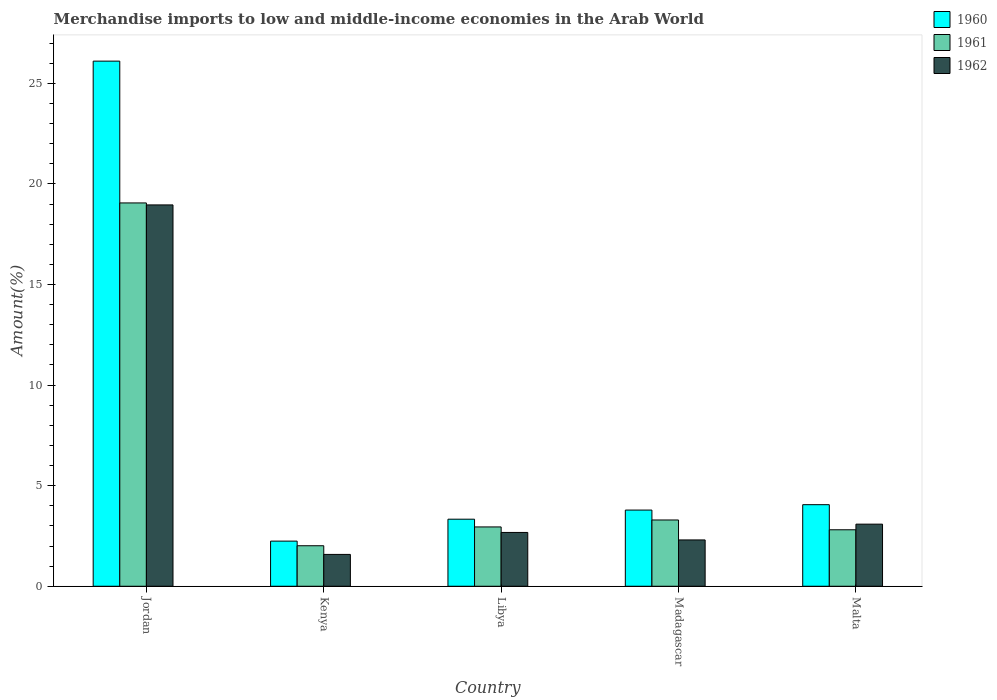How many different coloured bars are there?
Offer a terse response. 3. How many groups of bars are there?
Ensure brevity in your answer.  5. Are the number of bars per tick equal to the number of legend labels?
Offer a very short reply. Yes. How many bars are there on the 1st tick from the left?
Keep it short and to the point. 3. How many bars are there on the 2nd tick from the right?
Provide a succinct answer. 3. What is the label of the 1st group of bars from the left?
Provide a succinct answer. Jordan. What is the percentage of amount earned from merchandise imports in 1961 in Jordan?
Your answer should be very brief. 19.06. Across all countries, what is the maximum percentage of amount earned from merchandise imports in 1961?
Ensure brevity in your answer.  19.06. Across all countries, what is the minimum percentage of amount earned from merchandise imports in 1960?
Your answer should be very brief. 2.24. In which country was the percentage of amount earned from merchandise imports in 1962 maximum?
Keep it short and to the point. Jordan. In which country was the percentage of amount earned from merchandise imports in 1961 minimum?
Your response must be concise. Kenya. What is the total percentage of amount earned from merchandise imports in 1960 in the graph?
Give a very brief answer. 39.52. What is the difference between the percentage of amount earned from merchandise imports in 1962 in Madagascar and that in Malta?
Give a very brief answer. -0.78. What is the difference between the percentage of amount earned from merchandise imports in 1961 in Kenya and the percentage of amount earned from merchandise imports in 1960 in Libya?
Your response must be concise. -1.32. What is the average percentage of amount earned from merchandise imports in 1960 per country?
Provide a short and direct response. 7.9. What is the difference between the percentage of amount earned from merchandise imports of/in 1962 and percentage of amount earned from merchandise imports of/in 1960 in Jordan?
Offer a terse response. -7.15. In how many countries, is the percentage of amount earned from merchandise imports in 1961 greater than 13 %?
Provide a succinct answer. 1. What is the ratio of the percentage of amount earned from merchandise imports in 1961 in Jordan to that in Malta?
Provide a short and direct response. 6.79. Is the percentage of amount earned from merchandise imports in 1962 in Jordan less than that in Madagascar?
Give a very brief answer. No. Is the difference between the percentage of amount earned from merchandise imports in 1962 in Libya and Malta greater than the difference between the percentage of amount earned from merchandise imports in 1960 in Libya and Malta?
Your answer should be compact. Yes. What is the difference between the highest and the second highest percentage of amount earned from merchandise imports in 1960?
Make the answer very short. 22.32. What is the difference between the highest and the lowest percentage of amount earned from merchandise imports in 1962?
Your response must be concise. 17.37. Is the sum of the percentage of amount earned from merchandise imports in 1960 in Jordan and Kenya greater than the maximum percentage of amount earned from merchandise imports in 1961 across all countries?
Ensure brevity in your answer.  Yes. What does the 2nd bar from the left in Madagascar represents?
Your answer should be compact. 1961. Are all the bars in the graph horizontal?
Your response must be concise. No. Are the values on the major ticks of Y-axis written in scientific E-notation?
Your response must be concise. No. Where does the legend appear in the graph?
Provide a short and direct response. Top right. How are the legend labels stacked?
Offer a very short reply. Vertical. What is the title of the graph?
Your response must be concise. Merchandise imports to low and middle-income economies in the Arab World. What is the label or title of the X-axis?
Your answer should be compact. Country. What is the label or title of the Y-axis?
Provide a succinct answer. Amount(%). What is the Amount(%) of 1960 in Jordan?
Your answer should be compact. 26.11. What is the Amount(%) of 1961 in Jordan?
Offer a terse response. 19.06. What is the Amount(%) of 1962 in Jordan?
Your answer should be compact. 18.96. What is the Amount(%) in 1960 in Kenya?
Make the answer very short. 2.24. What is the Amount(%) in 1961 in Kenya?
Ensure brevity in your answer.  2.01. What is the Amount(%) of 1962 in Kenya?
Offer a terse response. 1.58. What is the Amount(%) in 1960 in Libya?
Offer a very short reply. 3.33. What is the Amount(%) of 1961 in Libya?
Keep it short and to the point. 2.95. What is the Amount(%) in 1962 in Libya?
Offer a very short reply. 2.68. What is the Amount(%) in 1960 in Madagascar?
Offer a terse response. 3.79. What is the Amount(%) in 1961 in Madagascar?
Your answer should be compact. 3.29. What is the Amount(%) of 1962 in Madagascar?
Provide a short and direct response. 2.3. What is the Amount(%) of 1960 in Malta?
Ensure brevity in your answer.  4.06. What is the Amount(%) in 1961 in Malta?
Keep it short and to the point. 2.81. What is the Amount(%) in 1962 in Malta?
Your response must be concise. 3.09. Across all countries, what is the maximum Amount(%) in 1960?
Offer a terse response. 26.11. Across all countries, what is the maximum Amount(%) in 1961?
Provide a short and direct response. 19.06. Across all countries, what is the maximum Amount(%) in 1962?
Offer a very short reply. 18.96. Across all countries, what is the minimum Amount(%) in 1960?
Offer a terse response. 2.24. Across all countries, what is the minimum Amount(%) in 1961?
Make the answer very short. 2.01. Across all countries, what is the minimum Amount(%) in 1962?
Your response must be concise. 1.58. What is the total Amount(%) of 1960 in the graph?
Ensure brevity in your answer.  39.52. What is the total Amount(%) of 1961 in the graph?
Provide a short and direct response. 30.12. What is the total Amount(%) in 1962 in the graph?
Your response must be concise. 28.61. What is the difference between the Amount(%) in 1960 in Jordan and that in Kenya?
Give a very brief answer. 23.86. What is the difference between the Amount(%) of 1961 in Jordan and that in Kenya?
Your answer should be very brief. 17.04. What is the difference between the Amount(%) in 1962 in Jordan and that in Kenya?
Your answer should be very brief. 17.37. What is the difference between the Amount(%) of 1960 in Jordan and that in Libya?
Offer a very short reply. 22.77. What is the difference between the Amount(%) of 1961 in Jordan and that in Libya?
Offer a very short reply. 16.11. What is the difference between the Amount(%) in 1962 in Jordan and that in Libya?
Provide a succinct answer. 16.28. What is the difference between the Amount(%) in 1960 in Jordan and that in Madagascar?
Your answer should be compact. 22.32. What is the difference between the Amount(%) of 1961 in Jordan and that in Madagascar?
Ensure brevity in your answer.  15.76. What is the difference between the Amount(%) in 1962 in Jordan and that in Madagascar?
Offer a very short reply. 16.65. What is the difference between the Amount(%) of 1960 in Jordan and that in Malta?
Give a very brief answer. 22.05. What is the difference between the Amount(%) of 1961 in Jordan and that in Malta?
Provide a succinct answer. 16.25. What is the difference between the Amount(%) of 1962 in Jordan and that in Malta?
Offer a terse response. 15.87. What is the difference between the Amount(%) of 1960 in Kenya and that in Libya?
Give a very brief answer. -1.09. What is the difference between the Amount(%) in 1961 in Kenya and that in Libya?
Your answer should be compact. -0.94. What is the difference between the Amount(%) of 1962 in Kenya and that in Libya?
Give a very brief answer. -1.09. What is the difference between the Amount(%) of 1960 in Kenya and that in Madagascar?
Make the answer very short. -1.54. What is the difference between the Amount(%) of 1961 in Kenya and that in Madagascar?
Your answer should be very brief. -1.28. What is the difference between the Amount(%) of 1962 in Kenya and that in Madagascar?
Offer a very short reply. -0.72. What is the difference between the Amount(%) in 1960 in Kenya and that in Malta?
Make the answer very short. -1.81. What is the difference between the Amount(%) of 1961 in Kenya and that in Malta?
Offer a very short reply. -0.79. What is the difference between the Amount(%) of 1962 in Kenya and that in Malta?
Offer a very short reply. -1.5. What is the difference between the Amount(%) of 1960 in Libya and that in Madagascar?
Your response must be concise. -0.45. What is the difference between the Amount(%) of 1961 in Libya and that in Madagascar?
Your response must be concise. -0.35. What is the difference between the Amount(%) in 1962 in Libya and that in Madagascar?
Your answer should be compact. 0.37. What is the difference between the Amount(%) in 1960 in Libya and that in Malta?
Make the answer very short. -0.72. What is the difference between the Amount(%) in 1961 in Libya and that in Malta?
Ensure brevity in your answer.  0.14. What is the difference between the Amount(%) of 1962 in Libya and that in Malta?
Offer a very short reply. -0.41. What is the difference between the Amount(%) in 1960 in Madagascar and that in Malta?
Offer a terse response. -0.27. What is the difference between the Amount(%) of 1961 in Madagascar and that in Malta?
Make the answer very short. 0.49. What is the difference between the Amount(%) in 1962 in Madagascar and that in Malta?
Your answer should be compact. -0.79. What is the difference between the Amount(%) in 1960 in Jordan and the Amount(%) in 1961 in Kenya?
Provide a short and direct response. 24.09. What is the difference between the Amount(%) of 1960 in Jordan and the Amount(%) of 1962 in Kenya?
Your answer should be compact. 24.52. What is the difference between the Amount(%) of 1961 in Jordan and the Amount(%) of 1962 in Kenya?
Provide a short and direct response. 17.47. What is the difference between the Amount(%) of 1960 in Jordan and the Amount(%) of 1961 in Libya?
Ensure brevity in your answer.  23.16. What is the difference between the Amount(%) in 1960 in Jordan and the Amount(%) in 1962 in Libya?
Keep it short and to the point. 23.43. What is the difference between the Amount(%) of 1961 in Jordan and the Amount(%) of 1962 in Libya?
Keep it short and to the point. 16.38. What is the difference between the Amount(%) of 1960 in Jordan and the Amount(%) of 1961 in Madagascar?
Offer a very short reply. 22.81. What is the difference between the Amount(%) in 1960 in Jordan and the Amount(%) in 1962 in Madagascar?
Provide a short and direct response. 23.8. What is the difference between the Amount(%) in 1961 in Jordan and the Amount(%) in 1962 in Madagascar?
Give a very brief answer. 16.75. What is the difference between the Amount(%) in 1960 in Jordan and the Amount(%) in 1961 in Malta?
Offer a very short reply. 23.3. What is the difference between the Amount(%) of 1960 in Jordan and the Amount(%) of 1962 in Malta?
Make the answer very short. 23.02. What is the difference between the Amount(%) of 1961 in Jordan and the Amount(%) of 1962 in Malta?
Your response must be concise. 15.97. What is the difference between the Amount(%) in 1960 in Kenya and the Amount(%) in 1961 in Libya?
Offer a very short reply. -0.71. What is the difference between the Amount(%) in 1960 in Kenya and the Amount(%) in 1962 in Libya?
Your response must be concise. -0.43. What is the difference between the Amount(%) of 1961 in Kenya and the Amount(%) of 1962 in Libya?
Provide a short and direct response. -0.66. What is the difference between the Amount(%) of 1960 in Kenya and the Amount(%) of 1961 in Madagascar?
Give a very brief answer. -1.05. What is the difference between the Amount(%) in 1960 in Kenya and the Amount(%) in 1962 in Madagascar?
Your answer should be very brief. -0.06. What is the difference between the Amount(%) in 1961 in Kenya and the Amount(%) in 1962 in Madagascar?
Ensure brevity in your answer.  -0.29. What is the difference between the Amount(%) in 1960 in Kenya and the Amount(%) in 1961 in Malta?
Provide a succinct answer. -0.56. What is the difference between the Amount(%) in 1960 in Kenya and the Amount(%) in 1962 in Malta?
Your response must be concise. -0.84. What is the difference between the Amount(%) of 1961 in Kenya and the Amount(%) of 1962 in Malta?
Offer a very short reply. -1.07. What is the difference between the Amount(%) in 1960 in Libya and the Amount(%) in 1961 in Madagascar?
Your response must be concise. 0.04. What is the difference between the Amount(%) of 1960 in Libya and the Amount(%) of 1962 in Madagascar?
Offer a terse response. 1.03. What is the difference between the Amount(%) in 1961 in Libya and the Amount(%) in 1962 in Madagascar?
Provide a short and direct response. 0.65. What is the difference between the Amount(%) in 1960 in Libya and the Amount(%) in 1961 in Malta?
Provide a succinct answer. 0.53. What is the difference between the Amount(%) of 1960 in Libya and the Amount(%) of 1962 in Malta?
Make the answer very short. 0.25. What is the difference between the Amount(%) of 1961 in Libya and the Amount(%) of 1962 in Malta?
Provide a short and direct response. -0.14. What is the difference between the Amount(%) of 1960 in Madagascar and the Amount(%) of 1961 in Malta?
Your response must be concise. 0.98. What is the difference between the Amount(%) of 1960 in Madagascar and the Amount(%) of 1962 in Malta?
Keep it short and to the point. 0.7. What is the difference between the Amount(%) in 1961 in Madagascar and the Amount(%) in 1962 in Malta?
Keep it short and to the point. 0.21. What is the average Amount(%) in 1960 per country?
Provide a succinct answer. 7.9. What is the average Amount(%) in 1961 per country?
Your answer should be very brief. 6.02. What is the average Amount(%) of 1962 per country?
Ensure brevity in your answer.  5.72. What is the difference between the Amount(%) in 1960 and Amount(%) in 1961 in Jordan?
Give a very brief answer. 7.05. What is the difference between the Amount(%) of 1960 and Amount(%) of 1962 in Jordan?
Provide a short and direct response. 7.15. What is the difference between the Amount(%) of 1961 and Amount(%) of 1962 in Jordan?
Provide a short and direct response. 0.1. What is the difference between the Amount(%) in 1960 and Amount(%) in 1961 in Kenya?
Offer a very short reply. 0.23. What is the difference between the Amount(%) of 1960 and Amount(%) of 1962 in Kenya?
Your response must be concise. 0.66. What is the difference between the Amount(%) of 1961 and Amount(%) of 1962 in Kenya?
Provide a short and direct response. 0.43. What is the difference between the Amount(%) of 1960 and Amount(%) of 1961 in Libya?
Ensure brevity in your answer.  0.38. What is the difference between the Amount(%) in 1960 and Amount(%) in 1962 in Libya?
Your answer should be compact. 0.66. What is the difference between the Amount(%) in 1961 and Amount(%) in 1962 in Libya?
Offer a terse response. 0.27. What is the difference between the Amount(%) of 1960 and Amount(%) of 1961 in Madagascar?
Keep it short and to the point. 0.49. What is the difference between the Amount(%) of 1960 and Amount(%) of 1962 in Madagascar?
Make the answer very short. 1.48. What is the difference between the Amount(%) in 1961 and Amount(%) in 1962 in Madagascar?
Offer a very short reply. 0.99. What is the difference between the Amount(%) in 1960 and Amount(%) in 1961 in Malta?
Your response must be concise. 1.25. What is the difference between the Amount(%) in 1960 and Amount(%) in 1962 in Malta?
Your answer should be very brief. 0.97. What is the difference between the Amount(%) of 1961 and Amount(%) of 1962 in Malta?
Offer a very short reply. -0.28. What is the ratio of the Amount(%) in 1960 in Jordan to that in Kenya?
Your answer should be compact. 11.64. What is the ratio of the Amount(%) in 1961 in Jordan to that in Kenya?
Ensure brevity in your answer.  9.46. What is the ratio of the Amount(%) of 1962 in Jordan to that in Kenya?
Provide a short and direct response. 11.98. What is the ratio of the Amount(%) in 1960 in Jordan to that in Libya?
Offer a terse response. 7.83. What is the ratio of the Amount(%) in 1961 in Jordan to that in Libya?
Give a very brief answer. 6.46. What is the ratio of the Amount(%) of 1962 in Jordan to that in Libya?
Keep it short and to the point. 7.09. What is the ratio of the Amount(%) of 1960 in Jordan to that in Madagascar?
Offer a terse response. 6.89. What is the ratio of the Amount(%) in 1961 in Jordan to that in Madagascar?
Keep it short and to the point. 5.78. What is the ratio of the Amount(%) in 1962 in Jordan to that in Madagascar?
Your answer should be compact. 8.23. What is the ratio of the Amount(%) in 1960 in Jordan to that in Malta?
Give a very brief answer. 6.44. What is the ratio of the Amount(%) of 1961 in Jordan to that in Malta?
Provide a succinct answer. 6.79. What is the ratio of the Amount(%) in 1962 in Jordan to that in Malta?
Keep it short and to the point. 6.14. What is the ratio of the Amount(%) in 1960 in Kenya to that in Libya?
Your response must be concise. 0.67. What is the ratio of the Amount(%) of 1961 in Kenya to that in Libya?
Offer a terse response. 0.68. What is the ratio of the Amount(%) in 1962 in Kenya to that in Libya?
Provide a succinct answer. 0.59. What is the ratio of the Amount(%) in 1960 in Kenya to that in Madagascar?
Make the answer very short. 0.59. What is the ratio of the Amount(%) in 1961 in Kenya to that in Madagascar?
Offer a terse response. 0.61. What is the ratio of the Amount(%) of 1962 in Kenya to that in Madagascar?
Ensure brevity in your answer.  0.69. What is the ratio of the Amount(%) in 1960 in Kenya to that in Malta?
Your answer should be very brief. 0.55. What is the ratio of the Amount(%) of 1961 in Kenya to that in Malta?
Offer a very short reply. 0.72. What is the ratio of the Amount(%) of 1962 in Kenya to that in Malta?
Provide a succinct answer. 0.51. What is the ratio of the Amount(%) in 1960 in Libya to that in Madagascar?
Your answer should be compact. 0.88. What is the ratio of the Amount(%) of 1961 in Libya to that in Madagascar?
Offer a very short reply. 0.9. What is the ratio of the Amount(%) of 1962 in Libya to that in Madagascar?
Keep it short and to the point. 1.16. What is the ratio of the Amount(%) of 1960 in Libya to that in Malta?
Keep it short and to the point. 0.82. What is the ratio of the Amount(%) in 1961 in Libya to that in Malta?
Ensure brevity in your answer.  1.05. What is the ratio of the Amount(%) of 1962 in Libya to that in Malta?
Keep it short and to the point. 0.87. What is the ratio of the Amount(%) in 1960 in Madagascar to that in Malta?
Offer a terse response. 0.93. What is the ratio of the Amount(%) in 1961 in Madagascar to that in Malta?
Keep it short and to the point. 1.17. What is the ratio of the Amount(%) in 1962 in Madagascar to that in Malta?
Offer a very short reply. 0.75. What is the difference between the highest and the second highest Amount(%) in 1960?
Provide a succinct answer. 22.05. What is the difference between the highest and the second highest Amount(%) of 1961?
Provide a short and direct response. 15.76. What is the difference between the highest and the second highest Amount(%) in 1962?
Ensure brevity in your answer.  15.87. What is the difference between the highest and the lowest Amount(%) in 1960?
Offer a terse response. 23.86. What is the difference between the highest and the lowest Amount(%) of 1961?
Your answer should be compact. 17.04. What is the difference between the highest and the lowest Amount(%) of 1962?
Provide a short and direct response. 17.37. 